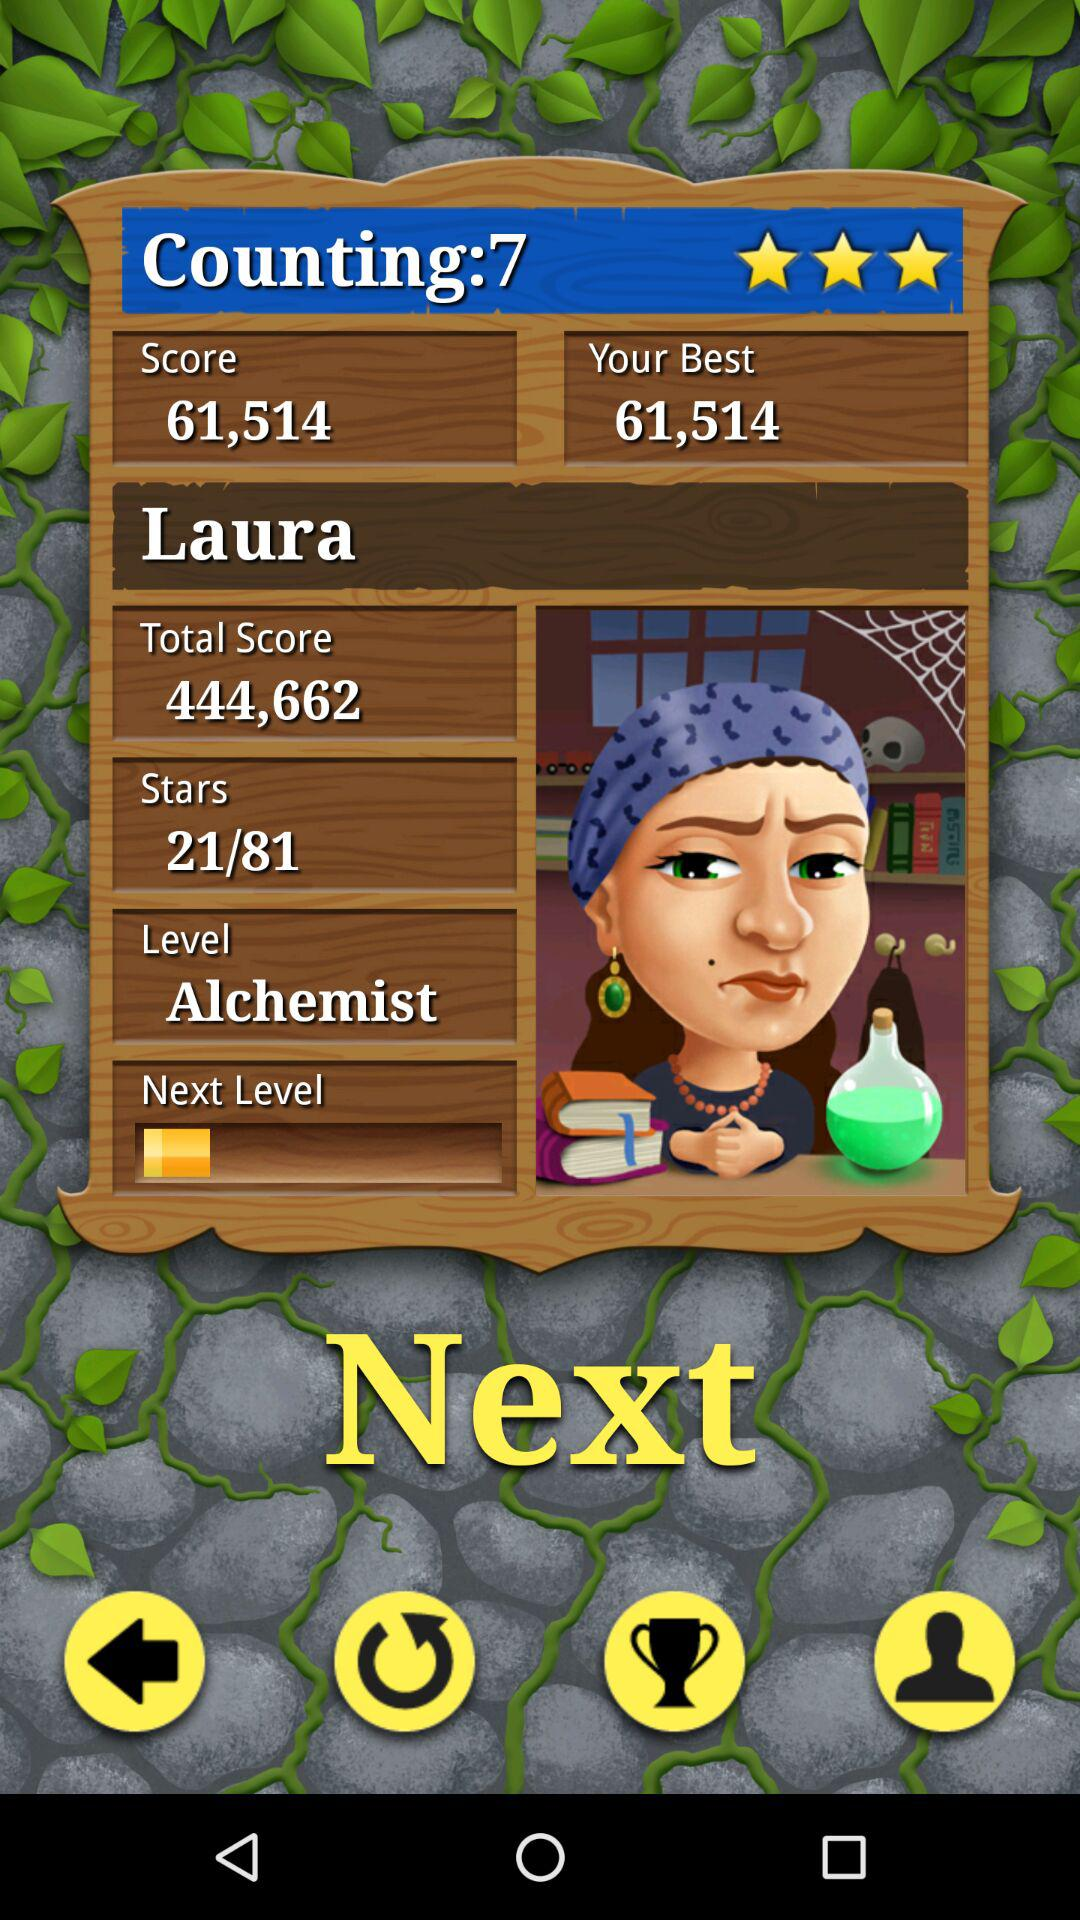How many stars are there out of 81? There are 21 stars out of 81. 